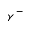<formula> <loc_0><loc_0><loc_500><loc_500>\gamma ^ { - }</formula> 